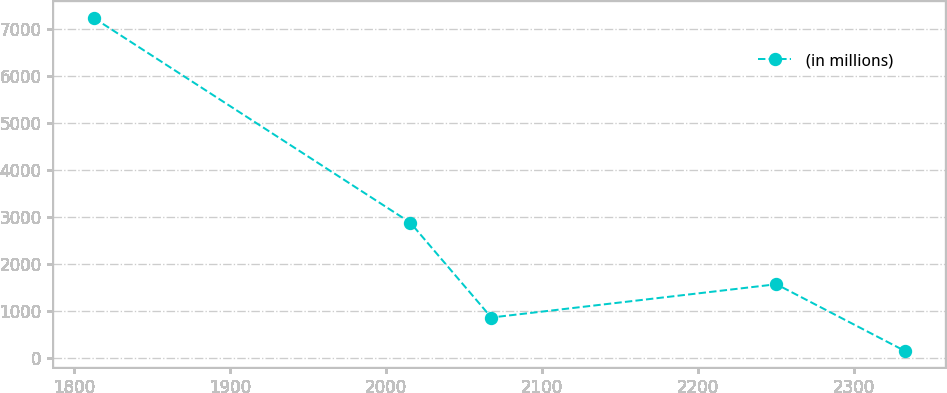Convert chart. <chart><loc_0><loc_0><loc_500><loc_500><line_chart><ecel><fcel>(in millions)<nl><fcel>1812.7<fcel>7237.02<nl><fcel>2015.46<fcel>2878.33<nl><fcel>2067.42<fcel>855.99<nl><fcel>2250.09<fcel>1564.99<nl><fcel>2332.28<fcel>146.99<nl></chart> 